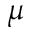<formula> <loc_0><loc_0><loc_500><loc_500>\mu</formula> 